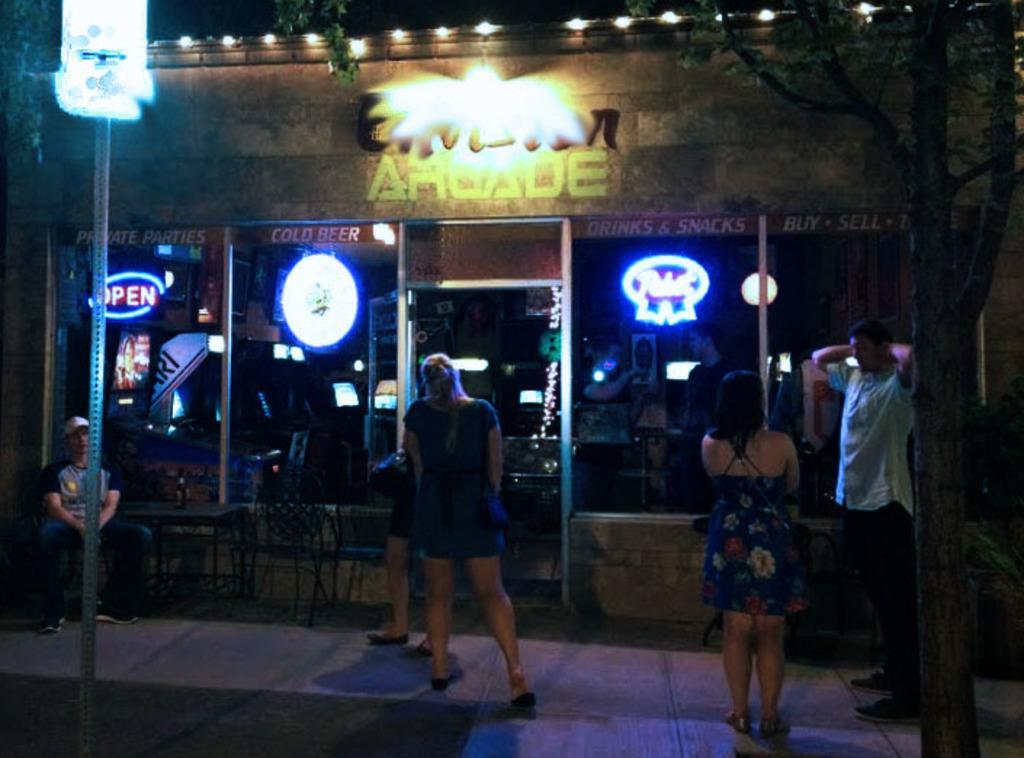Can you describe this image briefly? This image is taken during the night time. In this image we can see the building. We can also see the lights, light pole. Image also consists of the chairs and also the table. We can see a person sitting and wearing the cap. We can also see the people standing on the path. On the right we can see the tree. 